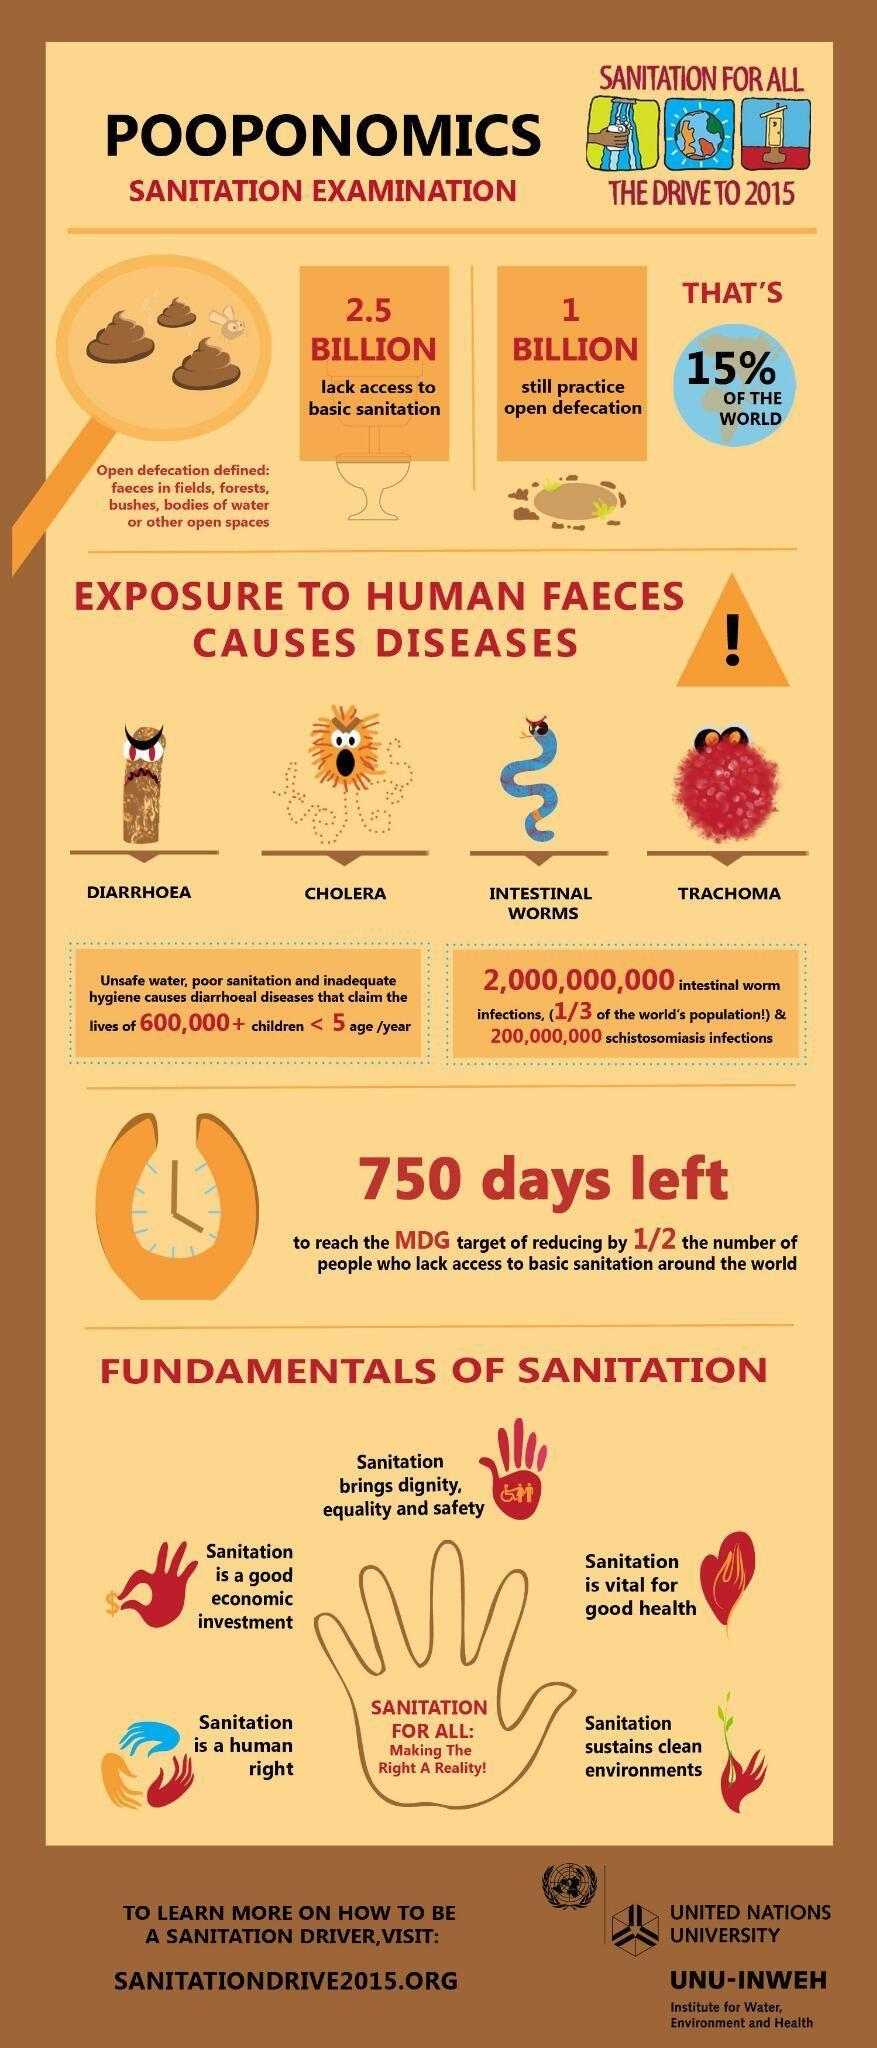What percentage of people  globally still practice open defecation?
Answer the question with a short phrase. 15% 